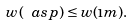<formula> <loc_0><loc_0><loc_500><loc_500>w ( \ a s p ) \leq w ( \i m ) .</formula> 